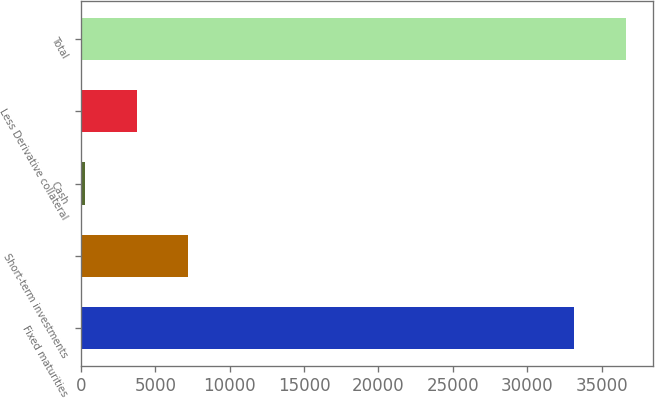Convert chart to OTSL. <chart><loc_0><loc_0><loc_500><loc_500><bar_chart><fcel>Fixed maturities<fcel>Short-term investments<fcel>Cash<fcel>Less Derivative collateral<fcel>Total<nl><fcel>33166<fcel>7227.4<fcel>280<fcel>3753.7<fcel>36639.7<nl></chart> 